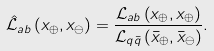<formula> <loc_0><loc_0><loc_500><loc_500>\hat { \mathcal { L } } _ { a b } \left ( x _ { \oplus } , x _ { \ominus } \right ) = \frac { \mathcal { L } _ { a b } \left ( x _ { \oplus } , x _ { \oplus } \right ) } { \mathcal { L } _ { q \bar { q } } \left ( \bar { x } _ { \oplus } , \bar { x } _ { \ominus } \right ) } .</formula> 